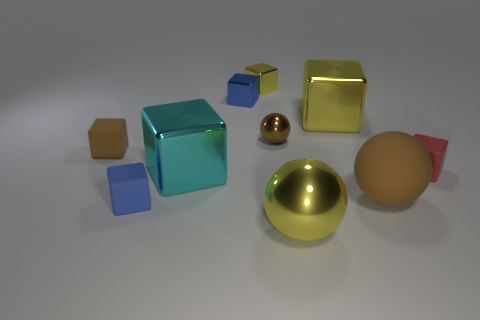Are there any other tiny blue rubber things of the same shape as the tiny blue matte thing?
Offer a very short reply. No. There is a small matte object that is in front of the large cyan object; is it the same shape as the large yellow thing to the right of the yellow ball?
Your answer should be compact. Yes. There is a brown thing that is both behind the small red object and right of the brown rubber cube; what shape is it?
Your answer should be very brief. Sphere. Is there a blue rubber cylinder of the same size as the brown matte ball?
Offer a very short reply. No. Is the color of the big metal ball the same as the big metallic cube behind the brown rubber block?
Offer a terse response. Yes. What is the big yellow cube made of?
Your response must be concise. Metal. What is the color of the ball that is behind the small red object?
Keep it short and to the point. Brown. What number of shiny things have the same color as the tiny ball?
Ensure brevity in your answer.  0. How many matte cubes are left of the red matte thing and behind the big brown ball?
Make the answer very short. 1. What shape is the red matte object that is the same size as the brown matte block?
Your response must be concise. Cube. 